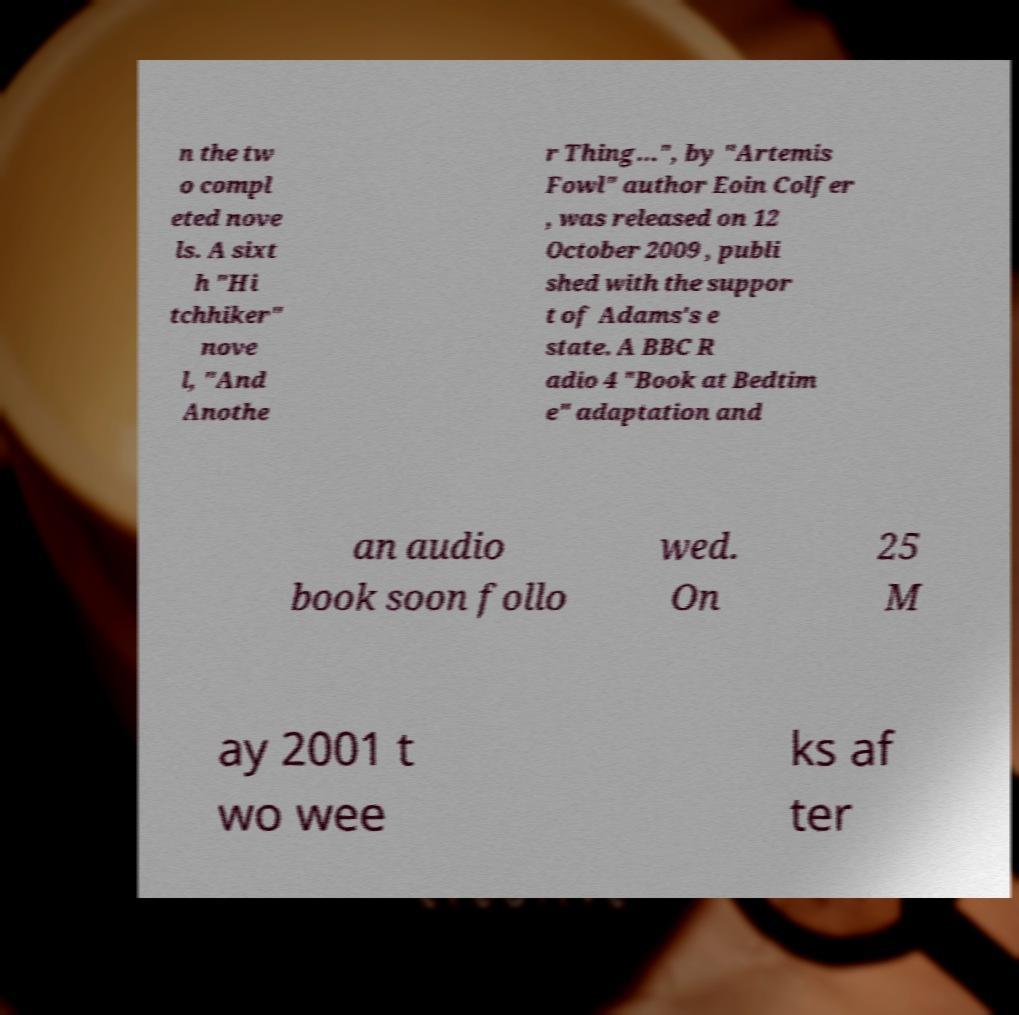Can you read and provide the text displayed in the image?This photo seems to have some interesting text. Can you extract and type it out for me? n the tw o compl eted nove ls. A sixt h "Hi tchhiker" nove l, "And Anothe r Thing...", by "Artemis Fowl" author Eoin Colfer , was released on 12 October 2009 , publi shed with the suppor t of Adams's e state. A BBC R adio 4 "Book at Bedtim e" adaptation and an audio book soon follo wed. On 25 M ay 2001 t wo wee ks af ter 